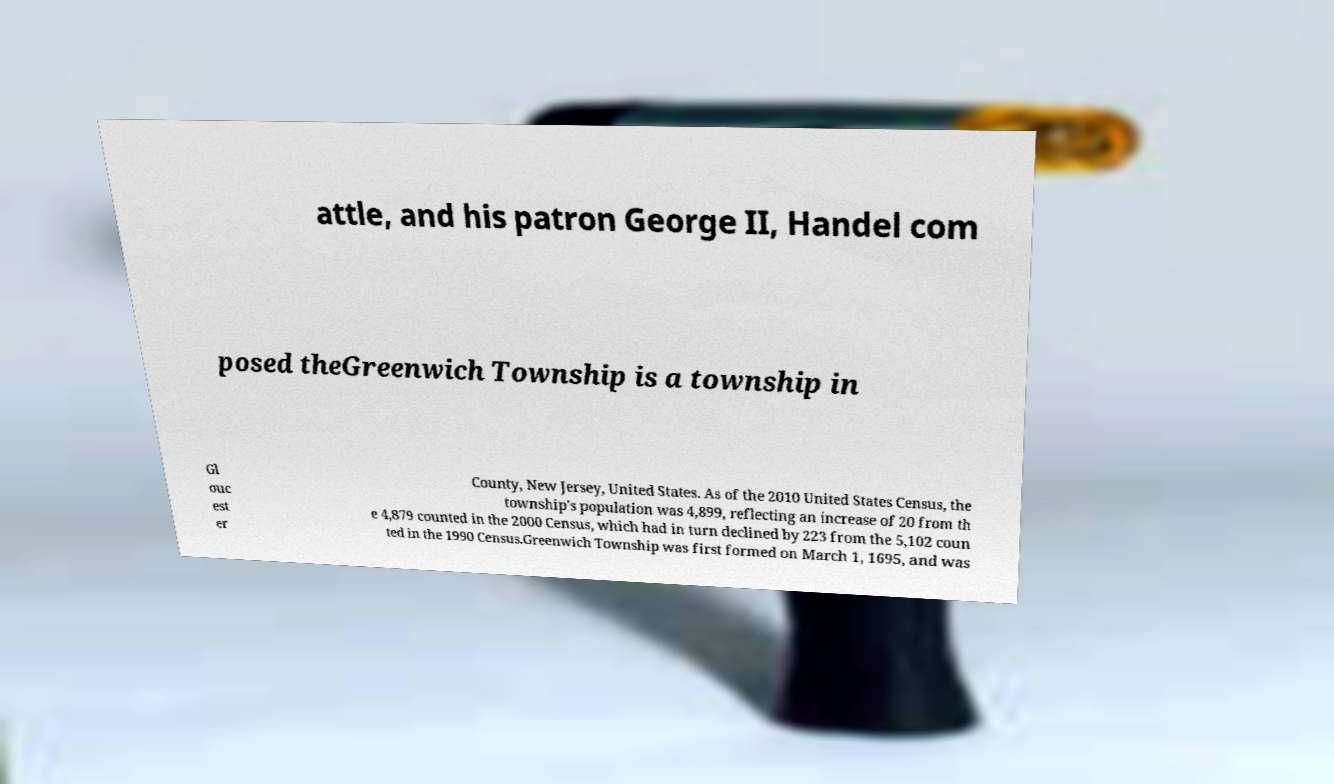I need the written content from this picture converted into text. Can you do that? attle, and his patron George II, Handel com posed theGreenwich Township is a township in Gl ouc est er County, New Jersey, United States. As of the 2010 United States Census, the township's population was 4,899, reflecting an increase of 20 from th e 4,879 counted in the 2000 Census, which had in turn declined by 223 from the 5,102 coun ted in the 1990 Census.Greenwich Township was first formed on March 1, 1695, and was 